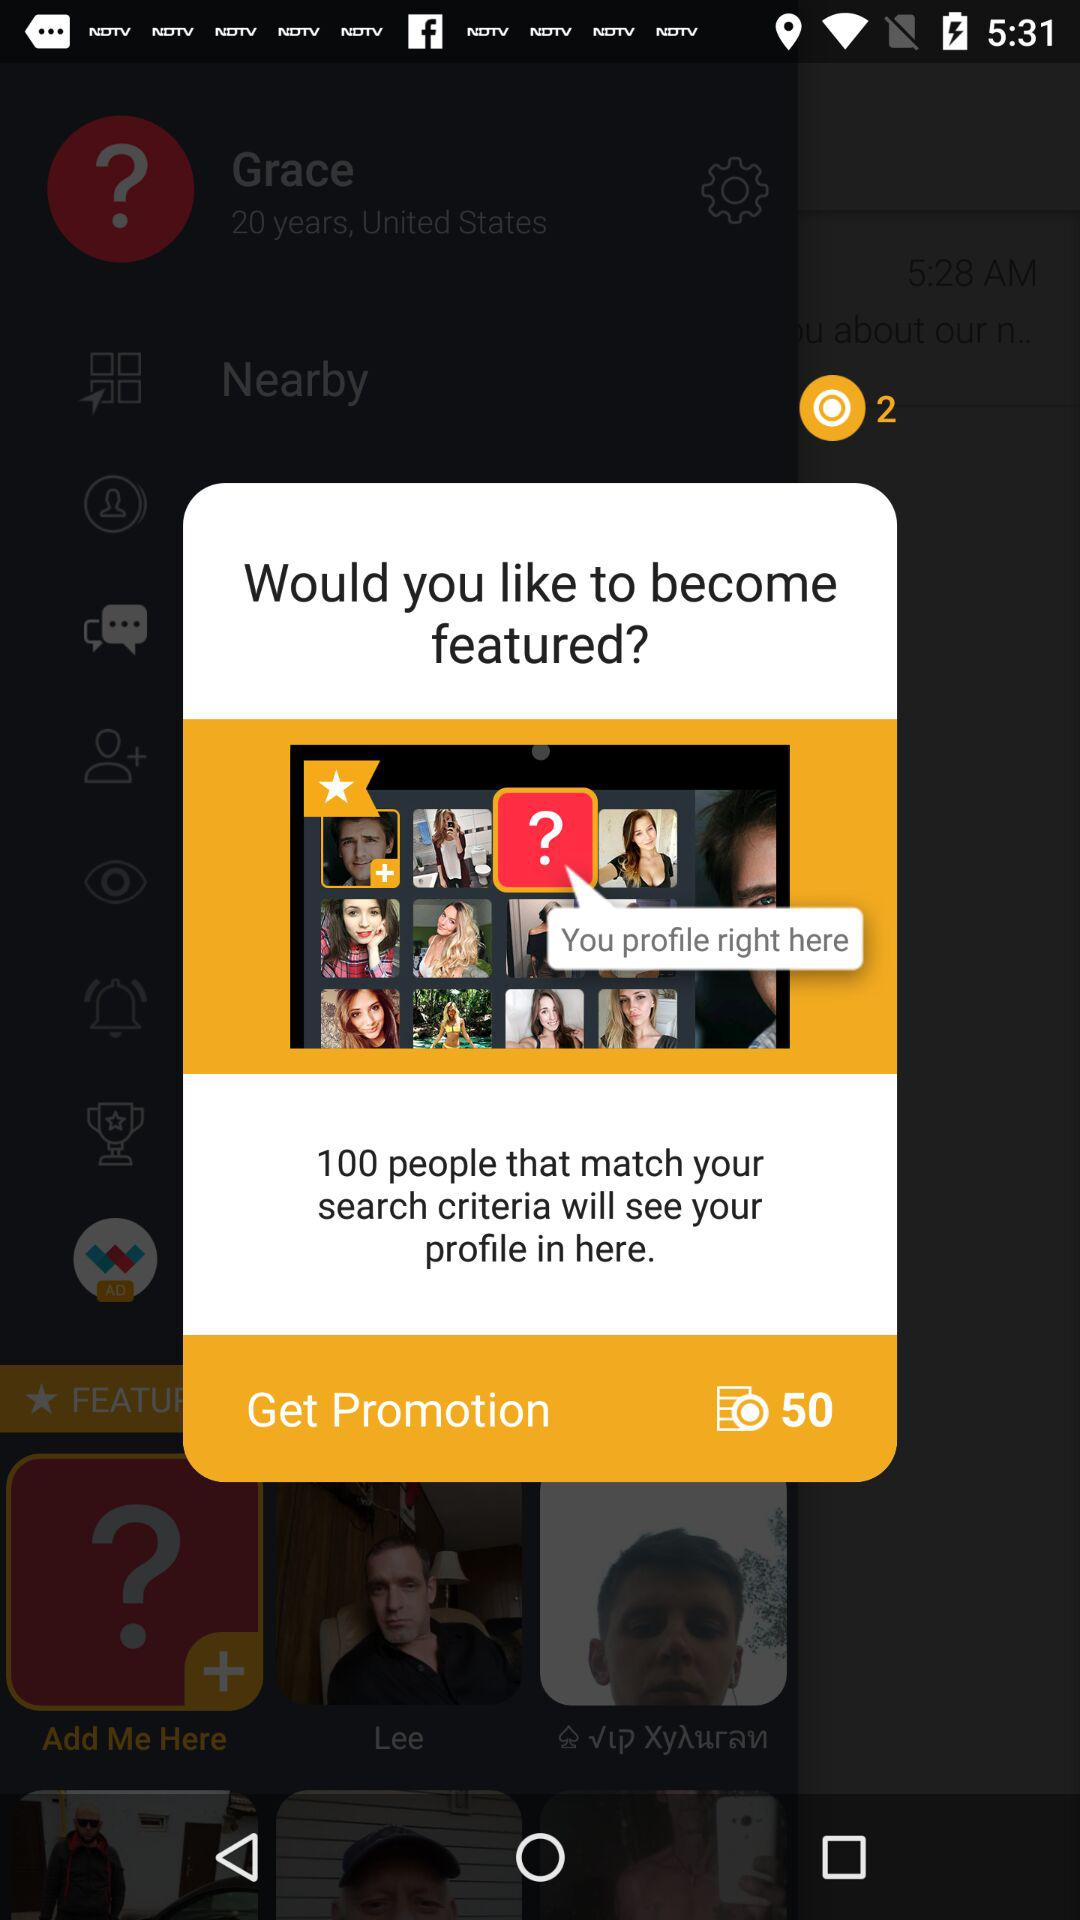What are the benefits of getting a profile featured on this platform? Being featured on this platform can increase your visibility to other users, possibly resulting in more engagement and connections. It may also enhance your reach according to the platform's search criteria and user interaction patterns. 